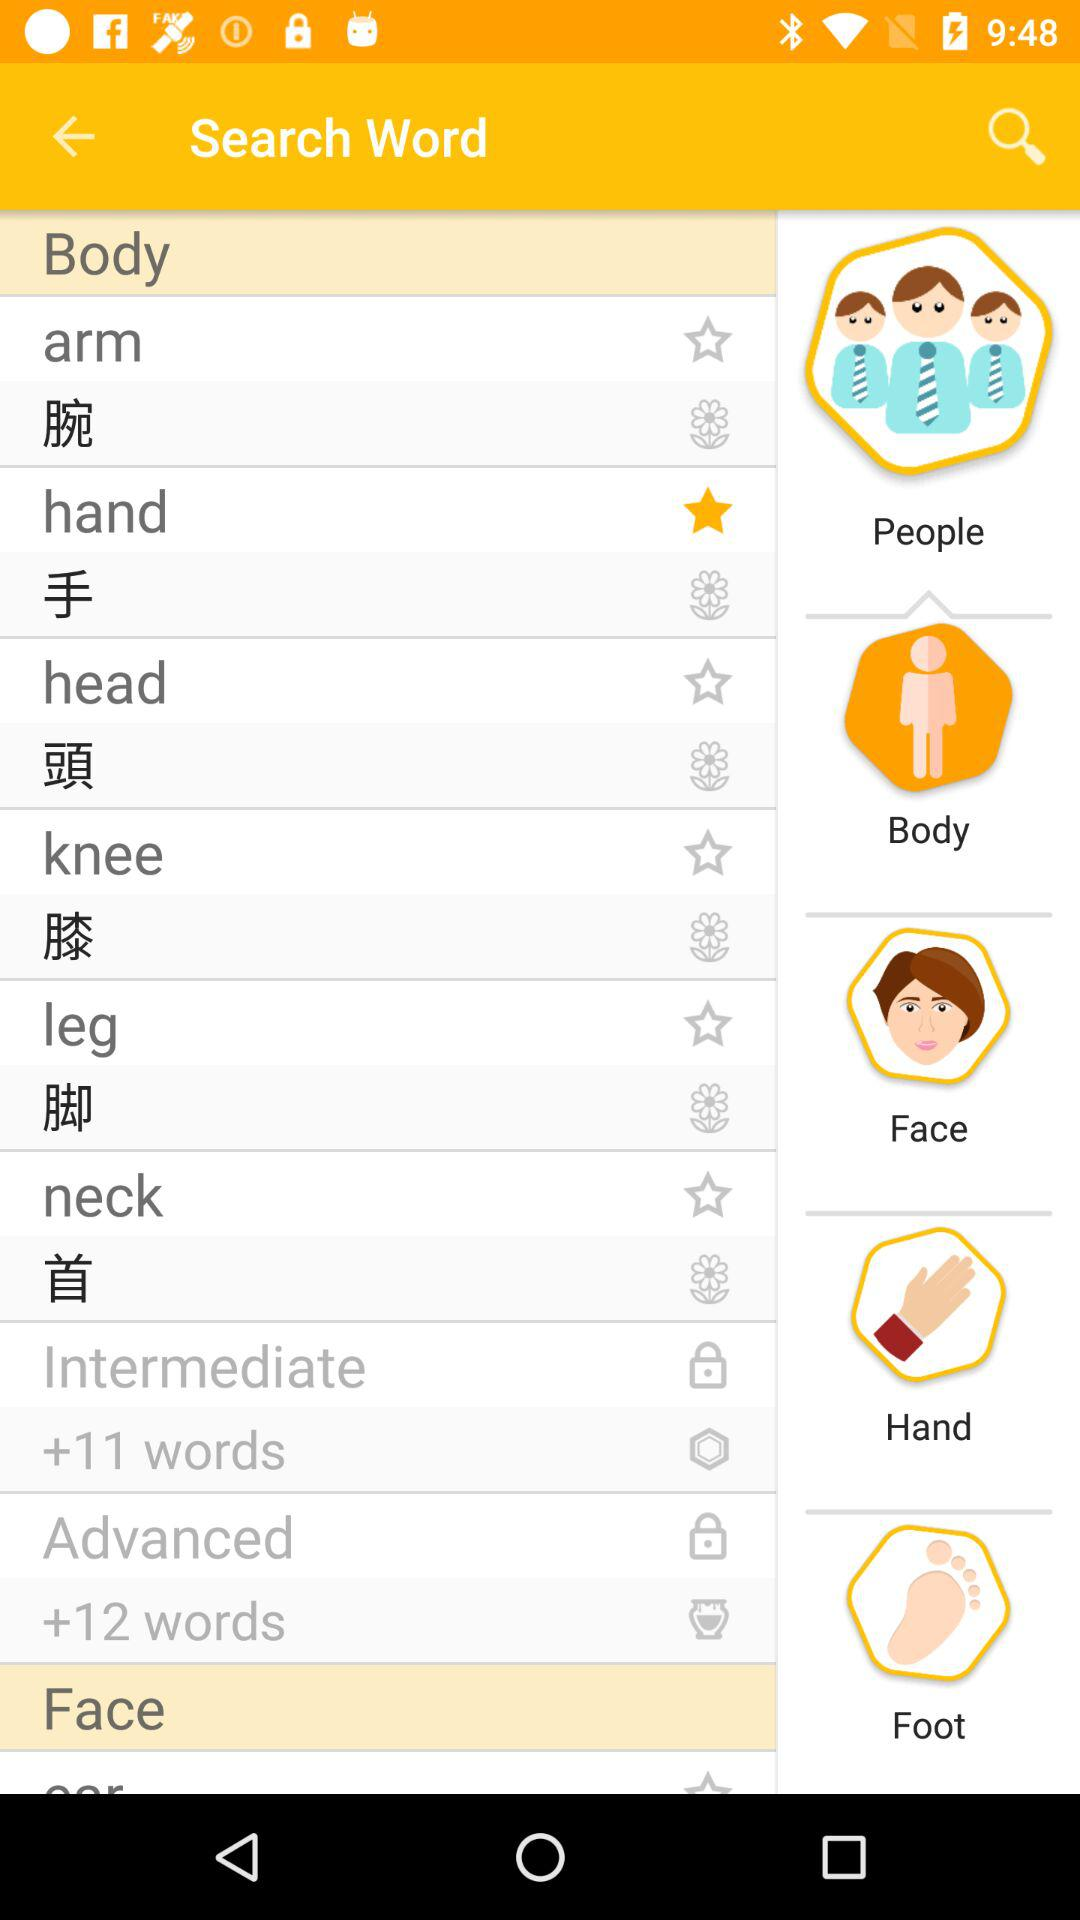How many words are there in "Advanced"? There are 12 words in "Advanced". 